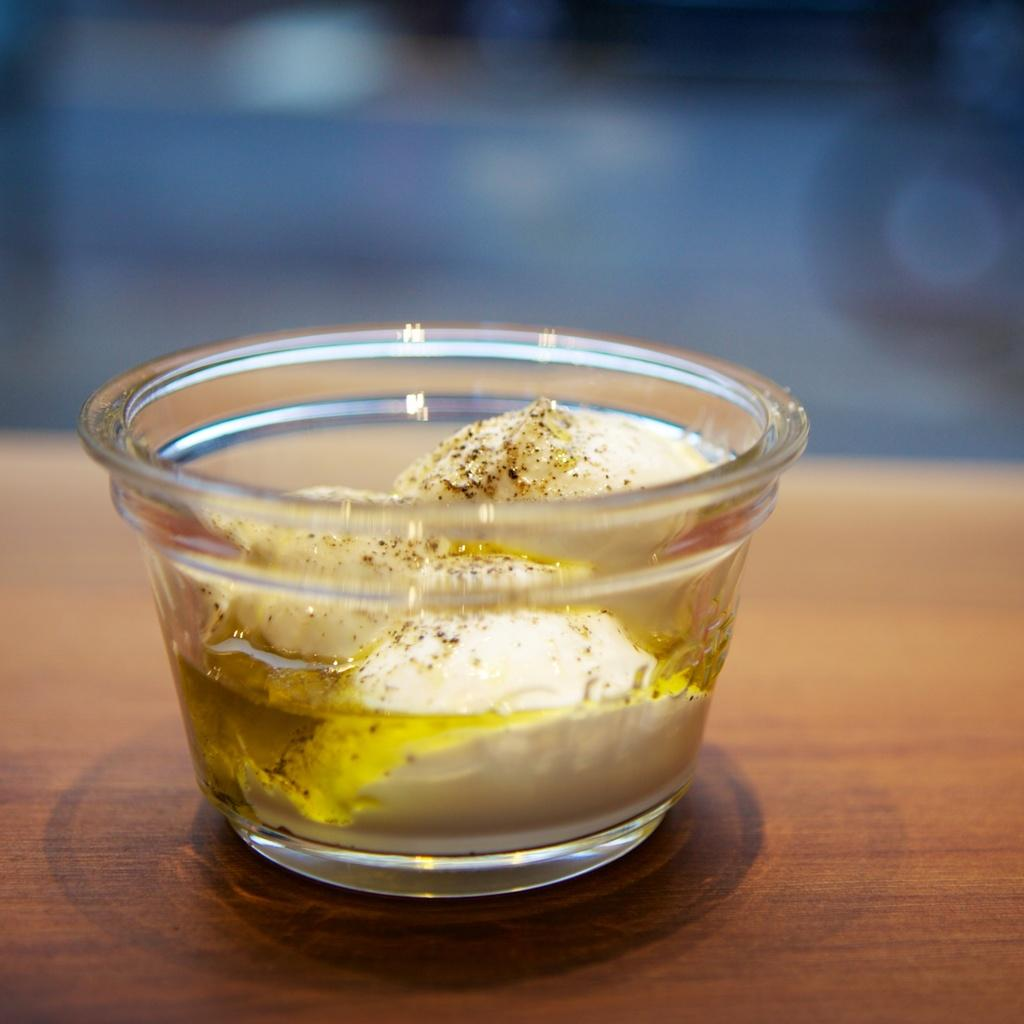What is in the glass cup that is visible in the image? There is food in the glass cup in the image. Where is the glass cup located? The glass cup is on a table. How many cents can be seen on the table next to the glass cup? There is no mention of any coins or currency in the image, so it is not possible to determine the number of cents present. 